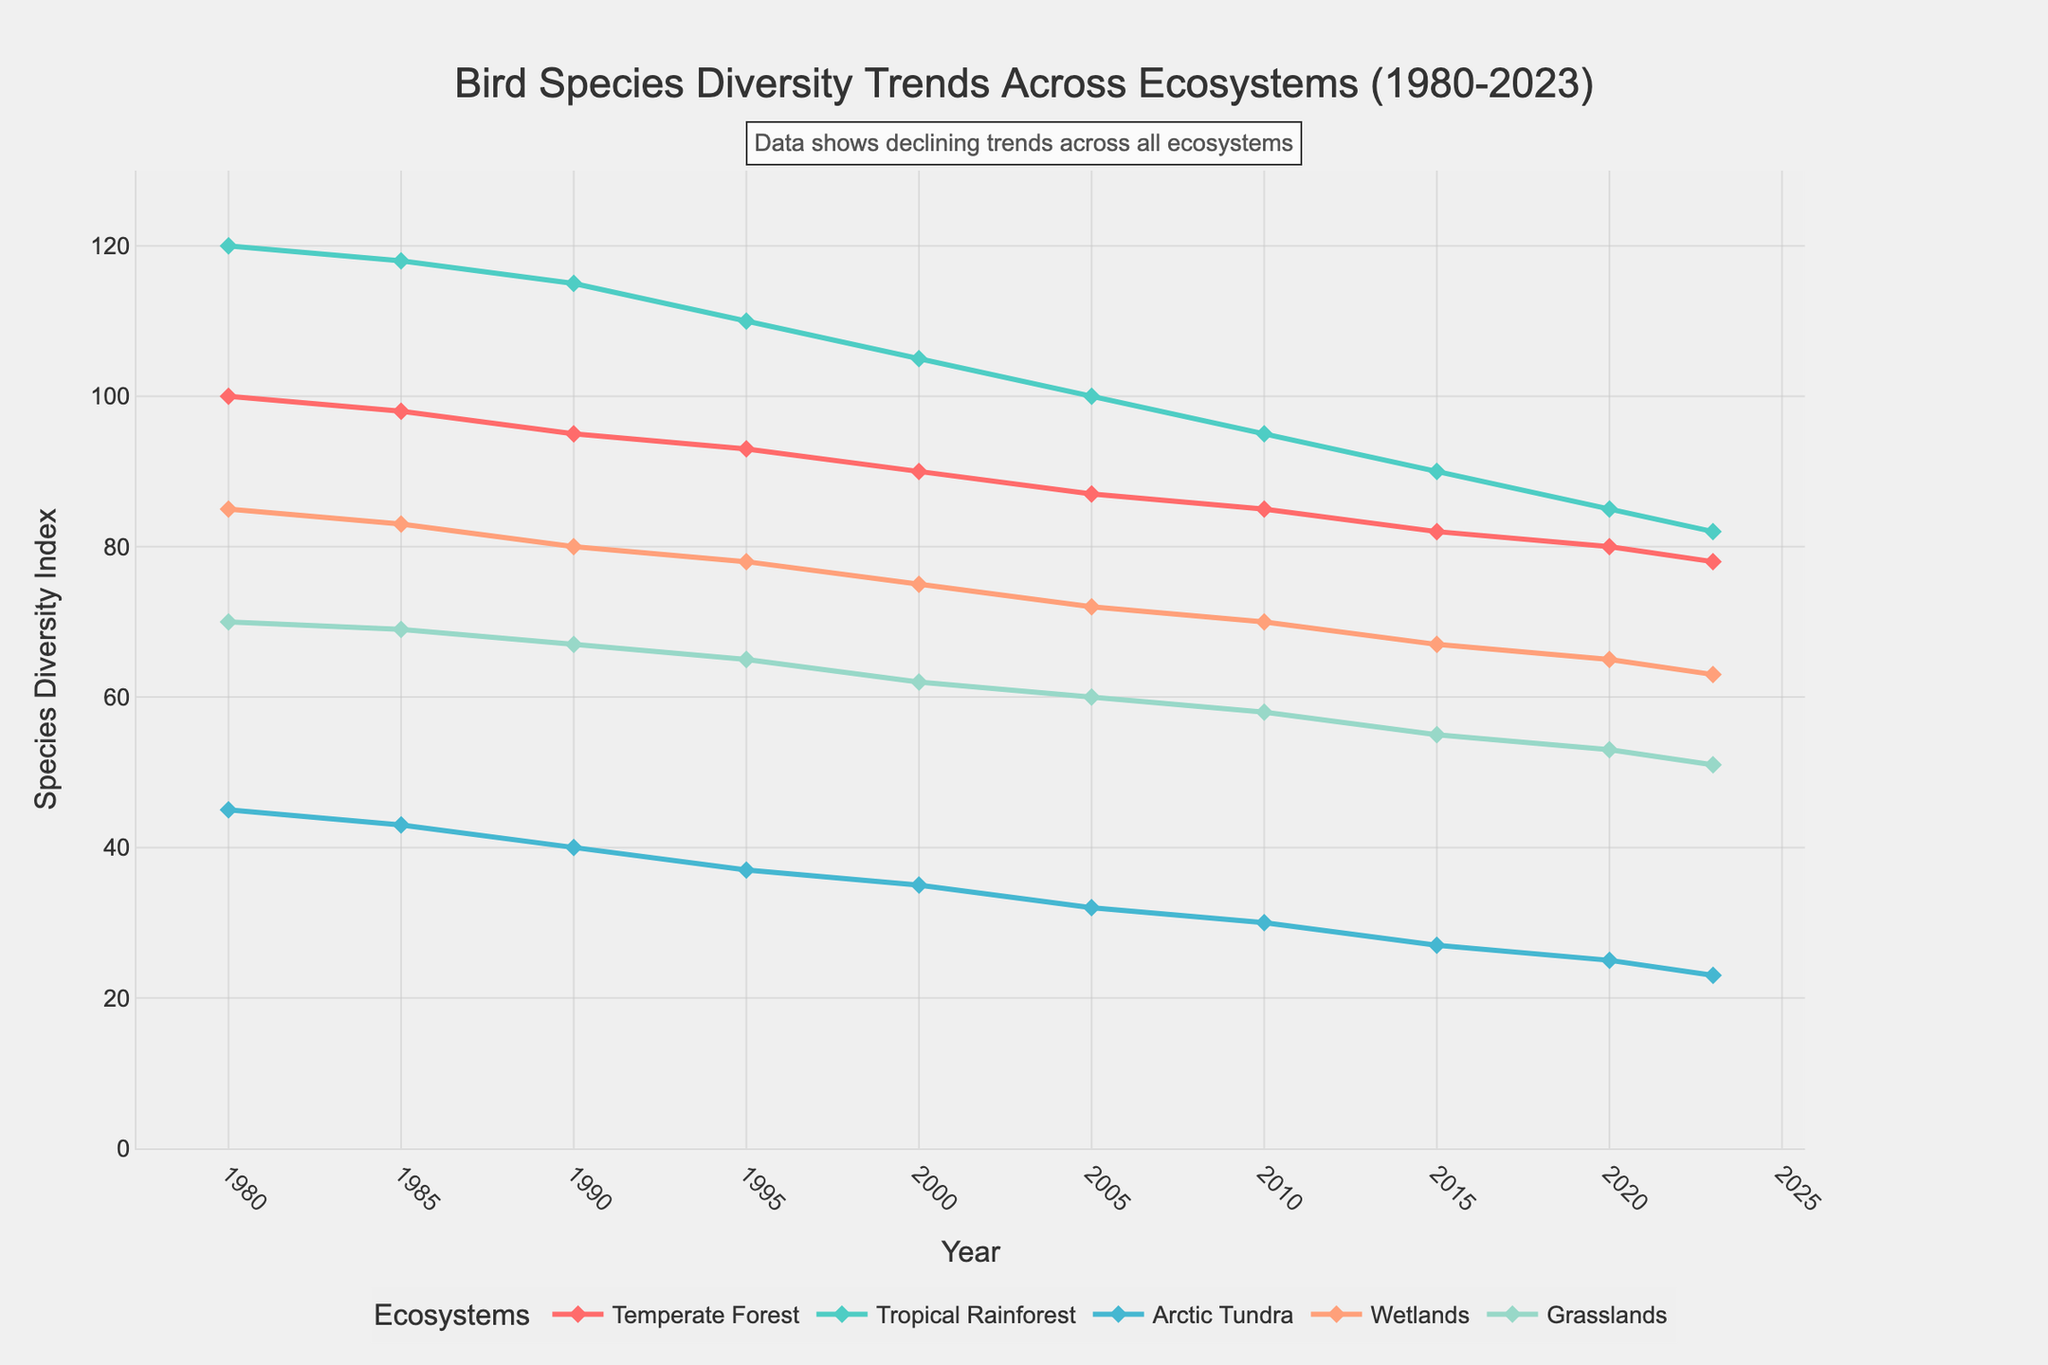What's the average species diversity index for the Temperate Forest across all years? Add up all the species diversity index values for the Temperate Forest (100 + 98 + 95 + 93 + 90 + 87 + 85 + 82 + 80 + 78) to get 888. Then divide by the number of data points, which is 10. So, 888/10 = 88.8
Answer: 88.8 Which ecosystem showed the highest species diversity index in 1980, and what was the value? In 1980, the species diversity indices for all ecosystems were: Temperate Forest (100), Tropical Rainforest (120), Arctic Tundra (45), Wetlands (85), and Grasslands (70). The highest value is 120, found in the Tropical Rainforest.
Answer: Tropical Rainforest, 120 How much did the species diversity index decrease in the Arctic Tundra from 1980 to 2023? Subtract the species diversity index in 2023 from the index in 1980 for the Arctic Tundra. This is 45 (in 1980) - 23 (in 2023) = 22.
Answer: 22 Which ecosystem had the smallest decrease in species diversity index from 2015 to 2023, and what is the value? Calculate the decreases for each ecosystem from 2015 to 2023: Temperate Forest (82 to 78, decrease of 4), Tropical Rainforest (90 to 82, decrease of 8), Arctic Tundra (27 to 23, decrease of 4), Wetlands (67 to 63, decrease of 4), Grasslands (55 to 51, decrease of 4). The smallest decrease is 4, shared by Temperate Forest, Arctic Tundra, Wetlands, and Grasslands.
Answer: Temperate Forest, Arctic Tundra, Wetlands, Grasslands, 4 Which year had the biggest drop in species diversity index for the Wetlands, and what was the value of the drop? Compare consecutive years for the Wetlands: 1980-1985 (85-83, drop of 2), 1985-1990 (83-80, drop of 3), 1990-1995 (80-78, drop of 2), 1995-2000 (78-75, drop of 3), 2000-2005 (75-72, drop of 3), 2005-2010 (72-70, drop of 2), 2010-2015 (70-67, drop of 3), 2015-2020 (67-65, drop of 2), 2020-2023 (65-63, drop of 2). The biggest drop is 3, which occurred in 1990-1995, 1995-2000, and 2010-2015.
Answer: 1990-1995, 1995-2000, 2010-2015, value of drop is 3 Compare the species diversity index trend in Grasslands and Arctic Tundra from 1980 to 2023. Which one had a steeper decline, and what is the value? For Grasslands, the decrease from 1980 to 2023 is 70 - 51 = 19. For Arctic Tundra, the decrease from 1980 to 2023 is 45 - 23 = 22. So, the Arctic Tundra had a steeper decline.
Answer: Arctic Tundra, 22 What color represents the line for the Tropical Rainforest, and what is its trend? The color representing the Tropical Rainforest is turquoise. The trend shows a decrease from 120 in 1980 to 82 in 2023.
Answer: Turquoise, decreasing Between which two years did the Tropical Rainforest see the smallest decline in species diversity index, and what is the value? For the Tropical Rainforest, compare the declines between consecutive years: 1980-1985 (120-118, decline of 2), 1985-1990 (118-115, decline of 3), 1990-1995 (115-110, decline of 5), 1995-2000 (110-105, decline of 5), 2000-2005 (105-100, decline of 5), 2005-2010 (100-95, decline of 5), 2010-2015 (95-90, decline of 5), 2015-2020 (90-85, decline of 5), 2020-2023 (85-82, decline of 3). The smallest decline is 2, which occurred between 1980 and 1985.
Answer: 1980-1985, 2 